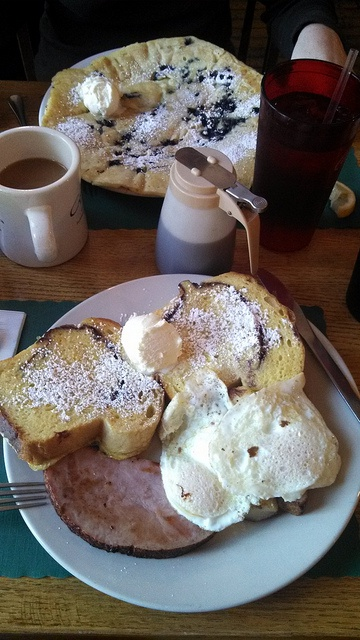Describe the objects in this image and their specific colors. I can see sandwich in black, lightgray, darkgray, tan, and lightblue tones, dining table in black, maroon, olive, and gray tones, sandwich in black, tan, darkgray, lightgray, and maroon tones, cup in black, gray, maroon, and darkgray tones, and cup in black, gray, darkgray, and maroon tones in this image. 